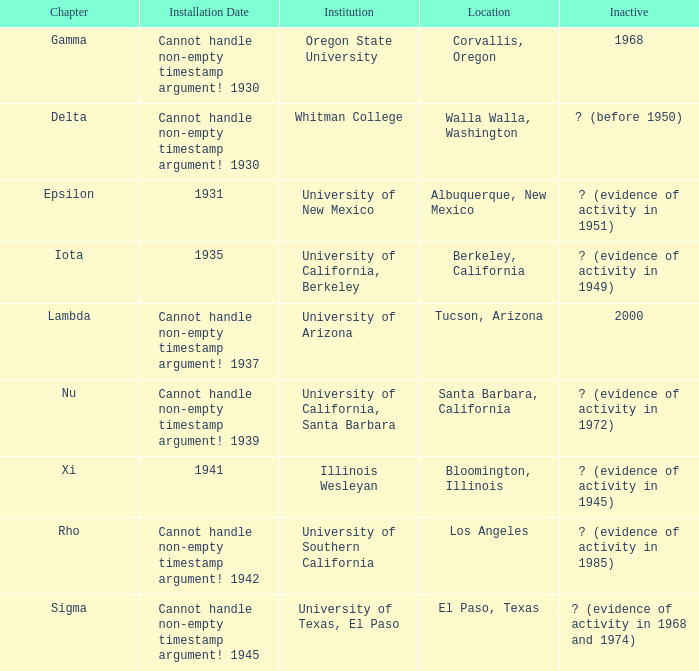What was the installation date in El Paso, Texas?  Cannot handle non-empty timestamp argument! 1945. 